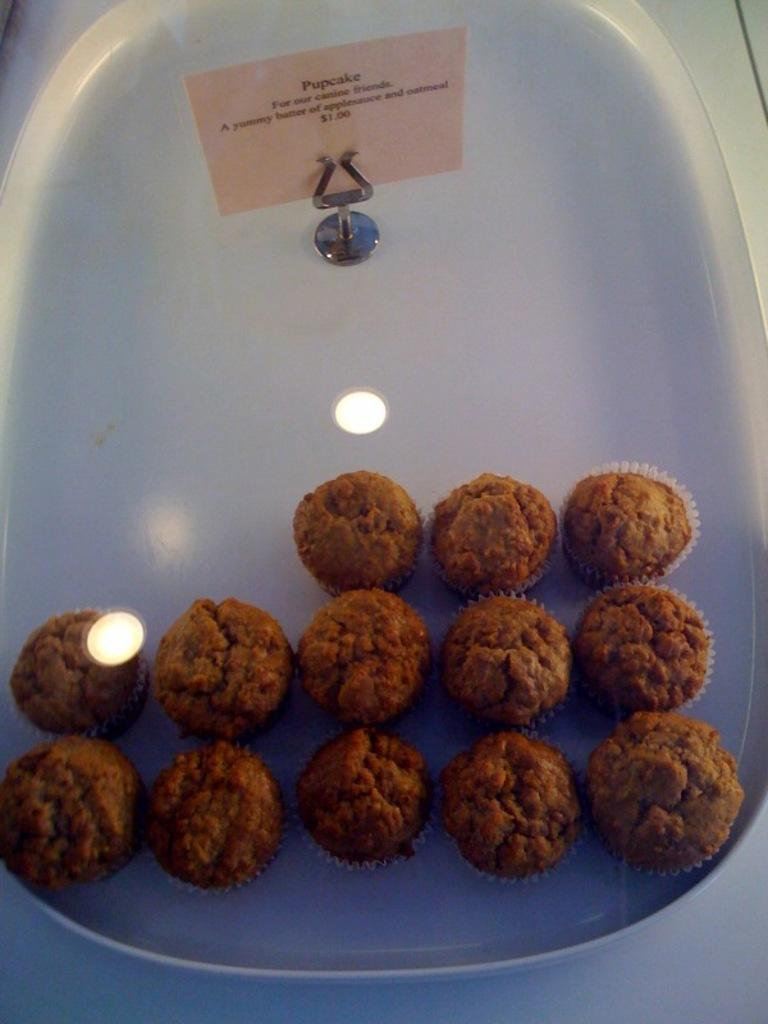What is on the tray that is visible in the image? There are food items on a tray in the image. What is the color of the tray? The tray is white in color. What else can be seen in the image besides the tray and food items? There is a paper with writing in the image. How does the son of the actor interact with the food items on the tray in the image? There is no son of an actor present in the image, nor is there any interaction with the food items. 